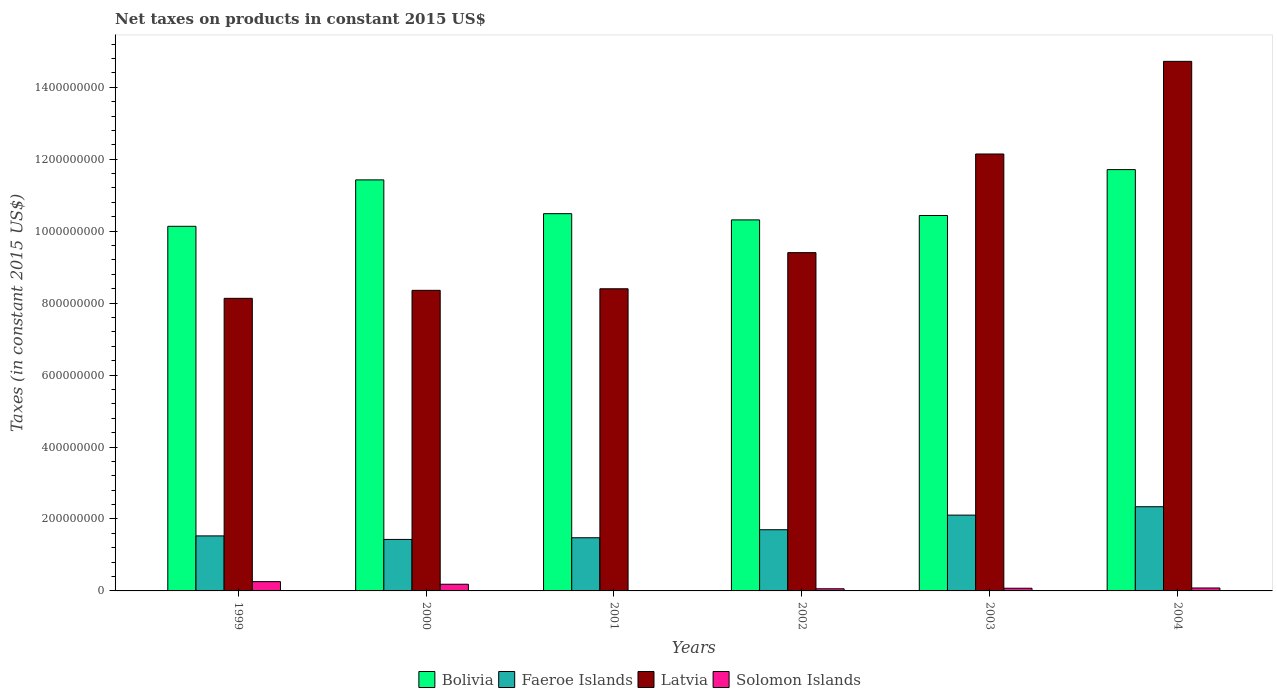How many groups of bars are there?
Give a very brief answer. 6. How many bars are there on the 6th tick from the right?
Give a very brief answer. 4. What is the net taxes on products in Faeroe Islands in 2002?
Offer a very short reply. 1.70e+08. Across all years, what is the maximum net taxes on products in Bolivia?
Provide a short and direct response. 1.17e+09. Across all years, what is the minimum net taxes on products in Latvia?
Give a very brief answer. 8.13e+08. In which year was the net taxes on products in Latvia maximum?
Keep it short and to the point. 2004. What is the total net taxes on products in Latvia in the graph?
Offer a very short reply. 6.12e+09. What is the difference between the net taxes on products in Faeroe Islands in 1999 and that in 2002?
Make the answer very short. -1.72e+07. What is the difference between the net taxes on products in Bolivia in 2003 and the net taxes on products in Latvia in 2004?
Your answer should be compact. -4.28e+08. What is the average net taxes on products in Solomon Islands per year?
Offer a very short reply. 1.10e+07. In the year 2003, what is the difference between the net taxes on products in Latvia and net taxes on products in Faeroe Islands?
Provide a succinct answer. 1.00e+09. In how many years, is the net taxes on products in Solomon Islands greater than 280000000 US$?
Keep it short and to the point. 0. What is the ratio of the net taxes on products in Solomon Islands in 2000 to that in 2002?
Your answer should be compact. 3.1. What is the difference between the highest and the second highest net taxes on products in Solomon Islands?
Make the answer very short. 7.27e+06. What is the difference between the highest and the lowest net taxes on products in Bolivia?
Offer a terse response. 1.58e+08. Is the sum of the net taxes on products in Latvia in 2000 and 2002 greater than the maximum net taxes on products in Solomon Islands across all years?
Provide a short and direct response. Yes. Is it the case that in every year, the sum of the net taxes on products in Latvia and net taxes on products in Bolivia is greater than the net taxes on products in Solomon Islands?
Provide a short and direct response. Yes. How many bars are there?
Offer a very short reply. 23. What is the difference between two consecutive major ticks on the Y-axis?
Your answer should be compact. 2.00e+08. Are the values on the major ticks of Y-axis written in scientific E-notation?
Keep it short and to the point. No. Does the graph contain grids?
Your response must be concise. No. Where does the legend appear in the graph?
Your response must be concise. Bottom center. How are the legend labels stacked?
Provide a short and direct response. Horizontal. What is the title of the graph?
Your answer should be compact. Net taxes on products in constant 2015 US$. What is the label or title of the Y-axis?
Provide a short and direct response. Taxes (in constant 2015 US$). What is the Taxes (in constant 2015 US$) in Bolivia in 1999?
Your answer should be compact. 1.01e+09. What is the Taxes (in constant 2015 US$) of Faeroe Islands in 1999?
Your answer should be compact. 1.53e+08. What is the Taxes (in constant 2015 US$) of Latvia in 1999?
Make the answer very short. 8.13e+08. What is the Taxes (in constant 2015 US$) in Solomon Islands in 1999?
Offer a terse response. 2.58e+07. What is the Taxes (in constant 2015 US$) in Bolivia in 2000?
Keep it short and to the point. 1.14e+09. What is the Taxes (in constant 2015 US$) of Faeroe Islands in 2000?
Your response must be concise. 1.43e+08. What is the Taxes (in constant 2015 US$) of Latvia in 2000?
Your answer should be compact. 8.36e+08. What is the Taxes (in constant 2015 US$) in Solomon Islands in 2000?
Offer a very short reply. 1.86e+07. What is the Taxes (in constant 2015 US$) of Bolivia in 2001?
Make the answer very short. 1.05e+09. What is the Taxes (in constant 2015 US$) of Faeroe Islands in 2001?
Offer a terse response. 1.48e+08. What is the Taxes (in constant 2015 US$) in Latvia in 2001?
Make the answer very short. 8.40e+08. What is the Taxes (in constant 2015 US$) in Bolivia in 2002?
Your answer should be compact. 1.03e+09. What is the Taxes (in constant 2015 US$) in Faeroe Islands in 2002?
Make the answer very short. 1.70e+08. What is the Taxes (in constant 2015 US$) in Latvia in 2002?
Your response must be concise. 9.40e+08. What is the Taxes (in constant 2015 US$) of Solomon Islands in 2002?
Your answer should be compact. 5.98e+06. What is the Taxes (in constant 2015 US$) in Bolivia in 2003?
Your answer should be very brief. 1.04e+09. What is the Taxes (in constant 2015 US$) of Faeroe Islands in 2003?
Your response must be concise. 2.11e+08. What is the Taxes (in constant 2015 US$) in Latvia in 2003?
Offer a terse response. 1.21e+09. What is the Taxes (in constant 2015 US$) of Solomon Islands in 2003?
Your response must be concise. 7.43e+06. What is the Taxes (in constant 2015 US$) of Bolivia in 2004?
Your response must be concise. 1.17e+09. What is the Taxes (in constant 2015 US$) of Faeroe Islands in 2004?
Offer a terse response. 2.34e+08. What is the Taxes (in constant 2015 US$) in Latvia in 2004?
Offer a terse response. 1.47e+09. What is the Taxes (in constant 2015 US$) of Solomon Islands in 2004?
Make the answer very short. 8.16e+06. Across all years, what is the maximum Taxes (in constant 2015 US$) in Bolivia?
Your answer should be compact. 1.17e+09. Across all years, what is the maximum Taxes (in constant 2015 US$) in Faeroe Islands?
Make the answer very short. 2.34e+08. Across all years, what is the maximum Taxes (in constant 2015 US$) in Latvia?
Keep it short and to the point. 1.47e+09. Across all years, what is the maximum Taxes (in constant 2015 US$) in Solomon Islands?
Your answer should be very brief. 2.58e+07. Across all years, what is the minimum Taxes (in constant 2015 US$) of Bolivia?
Provide a short and direct response. 1.01e+09. Across all years, what is the minimum Taxes (in constant 2015 US$) of Faeroe Islands?
Your answer should be very brief. 1.43e+08. Across all years, what is the minimum Taxes (in constant 2015 US$) of Latvia?
Your answer should be very brief. 8.13e+08. What is the total Taxes (in constant 2015 US$) in Bolivia in the graph?
Ensure brevity in your answer.  6.45e+09. What is the total Taxes (in constant 2015 US$) in Faeroe Islands in the graph?
Your response must be concise. 1.06e+09. What is the total Taxes (in constant 2015 US$) in Latvia in the graph?
Offer a terse response. 6.12e+09. What is the total Taxes (in constant 2015 US$) in Solomon Islands in the graph?
Offer a terse response. 6.59e+07. What is the difference between the Taxes (in constant 2015 US$) in Bolivia in 1999 and that in 2000?
Provide a succinct answer. -1.29e+08. What is the difference between the Taxes (in constant 2015 US$) of Faeroe Islands in 1999 and that in 2000?
Make the answer very short. 9.81e+06. What is the difference between the Taxes (in constant 2015 US$) of Latvia in 1999 and that in 2000?
Your response must be concise. -2.22e+07. What is the difference between the Taxes (in constant 2015 US$) in Solomon Islands in 1999 and that in 2000?
Your response must be concise. 7.27e+06. What is the difference between the Taxes (in constant 2015 US$) of Bolivia in 1999 and that in 2001?
Provide a short and direct response. -3.51e+07. What is the difference between the Taxes (in constant 2015 US$) of Faeroe Islands in 1999 and that in 2001?
Keep it short and to the point. 5.16e+06. What is the difference between the Taxes (in constant 2015 US$) of Latvia in 1999 and that in 2001?
Keep it short and to the point. -2.66e+07. What is the difference between the Taxes (in constant 2015 US$) of Bolivia in 1999 and that in 2002?
Keep it short and to the point. -1.78e+07. What is the difference between the Taxes (in constant 2015 US$) of Faeroe Islands in 1999 and that in 2002?
Your answer should be compact. -1.72e+07. What is the difference between the Taxes (in constant 2015 US$) of Latvia in 1999 and that in 2002?
Ensure brevity in your answer.  -1.27e+08. What is the difference between the Taxes (in constant 2015 US$) in Solomon Islands in 1999 and that in 2002?
Provide a succinct answer. 1.98e+07. What is the difference between the Taxes (in constant 2015 US$) in Bolivia in 1999 and that in 2003?
Offer a terse response. -3.01e+07. What is the difference between the Taxes (in constant 2015 US$) in Faeroe Islands in 1999 and that in 2003?
Offer a terse response. -5.77e+07. What is the difference between the Taxes (in constant 2015 US$) in Latvia in 1999 and that in 2003?
Keep it short and to the point. -4.01e+08. What is the difference between the Taxes (in constant 2015 US$) of Solomon Islands in 1999 and that in 2003?
Your answer should be very brief. 1.84e+07. What is the difference between the Taxes (in constant 2015 US$) in Bolivia in 1999 and that in 2004?
Make the answer very short. -1.58e+08. What is the difference between the Taxes (in constant 2015 US$) in Faeroe Islands in 1999 and that in 2004?
Provide a short and direct response. -8.11e+07. What is the difference between the Taxes (in constant 2015 US$) in Latvia in 1999 and that in 2004?
Give a very brief answer. -6.59e+08. What is the difference between the Taxes (in constant 2015 US$) in Solomon Islands in 1999 and that in 2004?
Your answer should be very brief. 1.77e+07. What is the difference between the Taxes (in constant 2015 US$) in Bolivia in 2000 and that in 2001?
Provide a short and direct response. 9.39e+07. What is the difference between the Taxes (in constant 2015 US$) of Faeroe Islands in 2000 and that in 2001?
Provide a succinct answer. -4.65e+06. What is the difference between the Taxes (in constant 2015 US$) of Latvia in 2000 and that in 2001?
Make the answer very short. -4.34e+06. What is the difference between the Taxes (in constant 2015 US$) of Bolivia in 2000 and that in 2002?
Your response must be concise. 1.11e+08. What is the difference between the Taxes (in constant 2015 US$) of Faeroe Islands in 2000 and that in 2002?
Offer a terse response. -2.70e+07. What is the difference between the Taxes (in constant 2015 US$) of Latvia in 2000 and that in 2002?
Keep it short and to the point. -1.05e+08. What is the difference between the Taxes (in constant 2015 US$) in Solomon Islands in 2000 and that in 2002?
Your answer should be compact. 1.26e+07. What is the difference between the Taxes (in constant 2015 US$) of Bolivia in 2000 and that in 2003?
Keep it short and to the point. 9.90e+07. What is the difference between the Taxes (in constant 2015 US$) of Faeroe Islands in 2000 and that in 2003?
Offer a terse response. -6.76e+07. What is the difference between the Taxes (in constant 2015 US$) in Latvia in 2000 and that in 2003?
Your response must be concise. -3.79e+08. What is the difference between the Taxes (in constant 2015 US$) of Solomon Islands in 2000 and that in 2003?
Provide a succinct answer. 1.11e+07. What is the difference between the Taxes (in constant 2015 US$) of Bolivia in 2000 and that in 2004?
Provide a short and direct response. -2.86e+07. What is the difference between the Taxes (in constant 2015 US$) in Faeroe Islands in 2000 and that in 2004?
Offer a very short reply. -9.09e+07. What is the difference between the Taxes (in constant 2015 US$) in Latvia in 2000 and that in 2004?
Your answer should be very brief. -6.36e+08. What is the difference between the Taxes (in constant 2015 US$) of Solomon Islands in 2000 and that in 2004?
Keep it short and to the point. 1.04e+07. What is the difference between the Taxes (in constant 2015 US$) of Bolivia in 2001 and that in 2002?
Your answer should be very brief. 1.73e+07. What is the difference between the Taxes (in constant 2015 US$) in Faeroe Islands in 2001 and that in 2002?
Offer a very short reply. -2.23e+07. What is the difference between the Taxes (in constant 2015 US$) in Latvia in 2001 and that in 2002?
Ensure brevity in your answer.  -1.00e+08. What is the difference between the Taxes (in constant 2015 US$) of Bolivia in 2001 and that in 2003?
Ensure brevity in your answer.  5.02e+06. What is the difference between the Taxes (in constant 2015 US$) of Faeroe Islands in 2001 and that in 2003?
Your answer should be very brief. -6.29e+07. What is the difference between the Taxes (in constant 2015 US$) in Latvia in 2001 and that in 2003?
Offer a very short reply. -3.75e+08. What is the difference between the Taxes (in constant 2015 US$) in Bolivia in 2001 and that in 2004?
Your answer should be very brief. -1.23e+08. What is the difference between the Taxes (in constant 2015 US$) in Faeroe Islands in 2001 and that in 2004?
Make the answer very short. -8.62e+07. What is the difference between the Taxes (in constant 2015 US$) in Latvia in 2001 and that in 2004?
Make the answer very short. -6.32e+08. What is the difference between the Taxes (in constant 2015 US$) in Bolivia in 2002 and that in 2003?
Offer a very short reply. -1.23e+07. What is the difference between the Taxes (in constant 2015 US$) of Faeroe Islands in 2002 and that in 2003?
Make the answer very short. -4.06e+07. What is the difference between the Taxes (in constant 2015 US$) of Latvia in 2002 and that in 2003?
Provide a short and direct response. -2.74e+08. What is the difference between the Taxes (in constant 2015 US$) in Solomon Islands in 2002 and that in 2003?
Make the answer very short. -1.46e+06. What is the difference between the Taxes (in constant 2015 US$) of Bolivia in 2002 and that in 2004?
Ensure brevity in your answer.  -1.40e+08. What is the difference between the Taxes (in constant 2015 US$) in Faeroe Islands in 2002 and that in 2004?
Your answer should be compact. -6.39e+07. What is the difference between the Taxes (in constant 2015 US$) of Latvia in 2002 and that in 2004?
Provide a succinct answer. -5.32e+08. What is the difference between the Taxes (in constant 2015 US$) in Solomon Islands in 2002 and that in 2004?
Keep it short and to the point. -2.18e+06. What is the difference between the Taxes (in constant 2015 US$) in Bolivia in 2003 and that in 2004?
Make the answer very short. -1.28e+08. What is the difference between the Taxes (in constant 2015 US$) in Faeroe Islands in 2003 and that in 2004?
Offer a terse response. -2.33e+07. What is the difference between the Taxes (in constant 2015 US$) of Latvia in 2003 and that in 2004?
Offer a terse response. -2.58e+08. What is the difference between the Taxes (in constant 2015 US$) of Solomon Islands in 2003 and that in 2004?
Keep it short and to the point. -7.29e+05. What is the difference between the Taxes (in constant 2015 US$) of Bolivia in 1999 and the Taxes (in constant 2015 US$) of Faeroe Islands in 2000?
Give a very brief answer. 8.70e+08. What is the difference between the Taxes (in constant 2015 US$) in Bolivia in 1999 and the Taxes (in constant 2015 US$) in Latvia in 2000?
Provide a succinct answer. 1.78e+08. What is the difference between the Taxes (in constant 2015 US$) in Bolivia in 1999 and the Taxes (in constant 2015 US$) in Solomon Islands in 2000?
Provide a short and direct response. 9.95e+08. What is the difference between the Taxes (in constant 2015 US$) of Faeroe Islands in 1999 and the Taxes (in constant 2015 US$) of Latvia in 2000?
Your response must be concise. -6.83e+08. What is the difference between the Taxes (in constant 2015 US$) of Faeroe Islands in 1999 and the Taxes (in constant 2015 US$) of Solomon Islands in 2000?
Keep it short and to the point. 1.34e+08. What is the difference between the Taxes (in constant 2015 US$) in Latvia in 1999 and the Taxes (in constant 2015 US$) in Solomon Islands in 2000?
Your response must be concise. 7.95e+08. What is the difference between the Taxes (in constant 2015 US$) of Bolivia in 1999 and the Taxes (in constant 2015 US$) of Faeroe Islands in 2001?
Provide a short and direct response. 8.66e+08. What is the difference between the Taxes (in constant 2015 US$) of Bolivia in 1999 and the Taxes (in constant 2015 US$) of Latvia in 2001?
Offer a terse response. 1.74e+08. What is the difference between the Taxes (in constant 2015 US$) of Faeroe Islands in 1999 and the Taxes (in constant 2015 US$) of Latvia in 2001?
Provide a succinct answer. -6.87e+08. What is the difference between the Taxes (in constant 2015 US$) in Bolivia in 1999 and the Taxes (in constant 2015 US$) in Faeroe Islands in 2002?
Your answer should be very brief. 8.43e+08. What is the difference between the Taxes (in constant 2015 US$) in Bolivia in 1999 and the Taxes (in constant 2015 US$) in Latvia in 2002?
Your response must be concise. 7.32e+07. What is the difference between the Taxes (in constant 2015 US$) of Bolivia in 1999 and the Taxes (in constant 2015 US$) of Solomon Islands in 2002?
Offer a very short reply. 1.01e+09. What is the difference between the Taxes (in constant 2015 US$) of Faeroe Islands in 1999 and the Taxes (in constant 2015 US$) of Latvia in 2002?
Make the answer very short. -7.87e+08. What is the difference between the Taxes (in constant 2015 US$) in Faeroe Islands in 1999 and the Taxes (in constant 2015 US$) in Solomon Islands in 2002?
Keep it short and to the point. 1.47e+08. What is the difference between the Taxes (in constant 2015 US$) in Latvia in 1999 and the Taxes (in constant 2015 US$) in Solomon Islands in 2002?
Make the answer very short. 8.07e+08. What is the difference between the Taxes (in constant 2015 US$) in Bolivia in 1999 and the Taxes (in constant 2015 US$) in Faeroe Islands in 2003?
Keep it short and to the point. 8.03e+08. What is the difference between the Taxes (in constant 2015 US$) in Bolivia in 1999 and the Taxes (in constant 2015 US$) in Latvia in 2003?
Your answer should be very brief. -2.01e+08. What is the difference between the Taxes (in constant 2015 US$) of Bolivia in 1999 and the Taxes (in constant 2015 US$) of Solomon Islands in 2003?
Your response must be concise. 1.01e+09. What is the difference between the Taxes (in constant 2015 US$) of Faeroe Islands in 1999 and the Taxes (in constant 2015 US$) of Latvia in 2003?
Your answer should be very brief. -1.06e+09. What is the difference between the Taxes (in constant 2015 US$) of Faeroe Islands in 1999 and the Taxes (in constant 2015 US$) of Solomon Islands in 2003?
Make the answer very short. 1.46e+08. What is the difference between the Taxes (in constant 2015 US$) of Latvia in 1999 and the Taxes (in constant 2015 US$) of Solomon Islands in 2003?
Offer a very short reply. 8.06e+08. What is the difference between the Taxes (in constant 2015 US$) in Bolivia in 1999 and the Taxes (in constant 2015 US$) in Faeroe Islands in 2004?
Give a very brief answer. 7.80e+08. What is the difference between the Taxes (in constant 2015 US$) in Bolivia in 1999 and the Taxes (in constant 2015 US$) in Latvia in 2004?
Your response must be concise. -4.59e+08. What is the difference between the Taxes (in constant 2015 US$) of Bolivia in 1999 and the Taxes (in constant 2015 US$) of Solomon Islands in 2004?
Provide a succinct answer. 1.01e+09. What is the difference between the Taxes (in constant 2015 US$) in Faeroe Islands in 1999 and the Taxes (in constant 2015 US$) in Latvia in 2004?
Give a very brief answer. -1.32e+09. What is the difference between the Taxes (in constant 2015 US$) in Faeroe Islands in 1999 and the Taxes (in constant 2015 US$) in Solomon Islands in 2004?
Keep it short and to the point. 1.45e+08. What is the difference between the Taxes (in constant 2015 US$) in Latvia in 1999 and the Taxes (in constant 2015 US$) in Solomon Islands in 2004?
Provide a succinct answer. 8.05e+08. What is the difference between the Taxes (in constant 2015 US$) of Bolivia in 2000 and the Taxes (in constant 2015 US$) of Faeroe Islands in 2001?
Give a very brief answer. 9.95e+08. What is the difference between the Taxes (in constant 2015 US$) of Bolivia in 2000 and the Taxes (in constant 2015 US$) of Latvia in 2001?
Provide a short and direct response. 3.03e+08. What is the difference between the Taxes (in constant 2015 US$) in Faeroe Islands in 2000 and the Taxes (in constant 2015 US$) in Latvia in 2001?
Give a very brief answer. -6.97e+08. What is the difference between the Taxes (in constant 2015 US$) in Bolivia in 2000 and the Taxes (in constant 2015 US$) in Faeroe Islands in 2002?
Your answer should be compact. 9.72e+08. What is the difference between the Taxes (in constant 2015 US$) in Bolivia in 2000 and the Taxes (in constant 2015 US$) in Latvia in 2002?
Give a very brief answer. 2.02e+08. What is the difference between the Taxes (in constant 2015 US$) in Bolivia in 2000 and the Taxes (in constant 2015 US$) in Solomon Islands in 2002?
Give a very brief answer. 1.14e+09. What is the difference between the Taxes (in constant 2015 US$) of Faeroe Islands in 2000 and the Taxes (in constant 2015 US$) of Latvia in 2002?
Your answer should be very brief. -7.97e+08. What is the difference between the Taxes (in constant 2015 US$) of Faeroe Islands in 2000 and the Taxes (in constant 2015 US$) of Solomon Islands in 2002?
Offer a terse response. 1.37e+08. What is the difference between the Taxes (in constant 2015 US$) of Latvia in 2000 and the Taxes (in constant 2015 US$) of Solomon Islands in 2002?
Your response must be concise. 8.30e+08. What is the difference between the Taxes (in constant 2015 US$) of Bolivia in 2000 and the Taxes (in constant 2015 US$) of Faeroe Islands in 2003?
Offer a terse response. 9.32e+08. What is the difference between the Taxes (in constant 2015 US$) in Bolivia in 2000 and the Taxes (in constant 2015 US$) in Latvia in 2003?
Give a very brief answer. -7.20e+07. What is the difference between the Taxes (in constant 2015 US$) of Bolivia in 2000 and the Taxes (in constant 2015 US$) of Solomon Islands in 2003?
Give a very brief answer. 1.14e+09. What is the difference between the Taxes (in constant 2015 US$) of Faeroe Islands in 2000 and the Taxes (in constant 2015 US$) of Latvia in 2003?
Keep it short and to the point. -1.07e+09. What is the difference between the Taxes (in constant 2015 US$) in Faeroe Islands in 2000 and the Taxes (in constant 2015 US$) in Solomon Islands in 2003?
Keep it short and to the point. 1.36e+08. What is the difference between the Taxes (in constant 2015 US$) of Latvia in 2000 and the Taxes (in constant 2015 US$) of Solomon Islands in 2003?
Keep it short and to the point. 8.28e+08. What is the difference between the Taxes (in constant 2015 US$) in Bolivia in 2000 and the Taxes (in constant 2015 US$) in Faeroe Islands in 2004?
Your answer should be compact. 9.09e+08. What is the difference between the Taxes (in constant 2015 US$) in Bolivia in 2000 and the Taxes (in constant 2015 US$) in Latvia in 2004?
Give a very brief answer. -3.29e+08. What is the difference between the Taxes (in constant 2015 US$) of Bolivia in 2000 and the Taxes (in constant 2015 US$) of Solomon Islands in 2004?
Offer a terse response. 1.13e+09. What is the difference between the Taxes (in constant 2015 US$) in Faeroe Islands in 2000 and the Taxes (in constant 2015 US$) in Latvia in 2004?
Provide a succinct answer. -1.33e+09. What is the difference between the Taxes (in constant 2015 US$) in Faeroe Islands in 2000 and the Taxes (in constant 2015 US$) in Solomon Islands in 2004?
Your answer should be very brief. 1.35e+08. What is the difference between the Taxes (in constant 2015 US$) in Latvia in 2000 and the Taxes (in constant 2015 US$) in Solomon Islands in 2004?
Ensure brevity in your answer.  8.27e+08. What is the difference between the Taxes (in constant 2015 US$) in Bolivia in 2001 and the Taxes (in constant 2015 US$) in Faeroe Islands in 2002?
Give a very brief answer. 8.79e+08. What is the difference between the Taxes (in constant 2015 US$) of Bolivia in 2001 and the Taxes (in constant 2015 US$) of Latvia in 2002?
Provide a short and direct response. 1.08e+08. What is the difference between the Taxes (in constant 2015 US$) in Bolivia in 2001 and the Taxes (in constant 2015 US$) in Solomon Islands in 2002?
Offer a terse response. 1.04e+09. What is the difference between the Taxes (in constant 2015 US$) of Faeroe Islands in 2001 and the Taxes (in constant 2015 US$) of Latvia in 2002?
Provide a succinct answer. -7.93e+08. What is the difference between the Taxes (in constant 2015 US$) of Faeroe Islands in 2001 and the Taxes (in constant 2015 US$) of Solomon Islands in 2002?
Offer a terse response. 1.42e+08. What is the difference between the Taxes (in constant 2015 US$) in Latvia in 2001 and the Taxes (in constant 2015 US$) in Solomon Islands in 2002?
Offer a very short reply. 8.34e+08. What is the difference between the Taxes (in constant 2015 US$) of Bolivia in 2001 and the Taxes (in constant 2015 US$) of Faeroe Islands in 2003?
Your response must be concise. 8.38e+08. What is the difference between the Taxes (in constant 2015 US$) in Bolivia in 2001 and the Taxes (in constant 2015 US$) in Latvia in 2003?
Your answer should be compact. -1.66e+08. What is the difference between the Taxes (in constant 2015 US$) in Bolivia in 2001 and the Taxes (in constant 2015 US$) in Solomon Islands in 2003?
Offer a very short reply. 1.04e+09. What is the difference between the Taxes (in constant 2015 US$) in Faeroe Islands in 2001 and the Taxes (in constant 2015 US$) in Latvia in 2003?
Your answer should be very brief. -1.07e+09. What is the difference between the Taxes (in constant 2015 US$) of Faeroe Islands in 2001 and the Taxes (in constant 2015 US$) of Solomon Islands in 2003?
Offer a terse response. 1.40e+08. What is the difference between the Taxes (in constant 2015 US$) of Latvia in 2001 and the Taxes (in constant 2015 US$) of Solomon Islands in 2003?
Make the answer very short. 8.32e+08. What is the difference between the Taxes (in constant 2015 US$) in Bolivia in 2001 and the Taxes (in constant 2015 US$) in Faeroe Islands in 2004?
Your answer should be compact. 8.15e+08. What is the difference between the Taxes (in constant 2015 US$) in Bolivia in 2001 and the Taxes (in constant 2015 US$) in Latvia in 2004?
Ensure brevity in your answer.  -4.23e+08. What is the difference between the Taxes (in constant 2015 US$) in Bolivia in 2001 and the Taxes (in constant 2015 US$) in Solomon Islands in 2004?
Your answer should be compact. 1.04e+09. What is the difference between the Taxes (in constant 2015 US$) of Faeroe Islands in 2001 and the Taxes (in constant 2015 US$) of Latvia in 2004?
Give a very brief answer. -1.32e+09. What is the difference between the Taxes (in constant 2015 US$) in Faeroe Islands in 2001 and the Taxes (in constant 2015 US$) in Solomon Islands in 2004?
Your answer should be very brief. 1.40e+08. What is the difference between the Taxes (in constant 2015 US$) in Latvia in 2001 and the Taxes (in constant 2015 US$) in Solomon Islands in 2004?
Your answer should be compact. 8.32e+08. What is the difference between the Taxes (in constant 2015 US$) in Bolivia in 2002 and the Taxes (in constant 2015 US$) in Faeroe Islands in 2003?
Your response must be concise. 8.21e+08. What is the difference between the Taxes (in constant 2015 US$) in Bolivia in 2002 and the Taxes (in constant 2015 US$) in Latvia in 2003?
Your answer should be compact. -1.83e+08. What is the difference between the Taxes (in constant 2015 US$) of Bolivia in 2002 and the Taxes (in constant 2015 US$) of Solomon Islands in 2003?
Offer a very short reply. 1.02e+09. What is the difference between the Taxes (in constant 2015 US$) in Faeroe Islands in 2002 and the Taxes (in constant 2015 US$) in Latvia in 2003?
Keep it short and to the point. -1.04e+09. What is the difference between the Taxes (in constant 2015 US$) of Faeroe Islands in 2002 and the Taxes (in constant 2015 US$) of Solomon Islands in 2003?
Your response must be concise. 1.63e+08. What is the difference between the Taxes (in constant 2015 US$) in Latvia in 2002 and the Taxes (in constant 2015 US$) in Solomon Islands in 2003?
Your answer should be very brief. 9.33e+08. What is the difference between the Taxes (in constant 2015 US$) of Bolivia in 2002 and the Taxes (in constant 2015 US$) of Faeroe Islands in 2004?
Your answer should be compact. 7.97e+08. What is the difference between the Taxes (in constant 2015 US$) in Bolivia in 2002 and the Taxes (in constant 2015 US$) in Latvia in 2004?
Provide a short and direct response. -4.41e+08. What is the difference between the Taxes (in constant 2015 US$) of Bolivia in 2002 and the Taxes (in constant 2015 US$) of Solomon Islands in 2004?
Keep it short and to the point. 1.02e+09. What is the difference between the Taxes (in constant 2015 US$) of Faeroe Islands in 2002 and the Taxes (in constant 2015 US$) of Latvia in 2004?
Ensure brevity in your answer.  -1.30e+09. What is the difference between the Taxes (in constant 2015 US$) in Faeroe Islands in 2002 and the Taxes (in constant 2015 US$) in Solomon Islands in 2004?
Give a very brief answer. 1.62e+08. What is the difference between the Taxes (in constant 2015 US$) of Latvia in 2002 and the Taxes (in constant 2015 US$) of Solomon Islands in 2004?
Provide a succinct answer. 9.32e+08. What is the difference between the Taxes (in constant 2015 US$) of Bolivia in 2003 and the Taxes (in constant 2015 US$) of Faeroe Islands in 2004?
Make the answer very short. 8.10e+08. What is the difference between the Taxes (in constant 2015 US$) of Bolivia in 2003 and the Taxes (in constant 2015 US$) of Latvia in 2004?
Offer a terse response. -4.28e+08. What is the difference between the Taxes (in constant 2015 US$) in Bolivia in 2003 and the Taxes (in constant 2015 US$) in Solomon Islands in 2004?
Your answer should be very brief. 1.04e+09. What is the difference between the Taxes (in constant 2015 US$) in Faeroe Islands in 2003 and the Taxes (in constant 2015 US$) in Latvia in 2004?
Provide a succinct answer. -1.26e+09. What is the difference between the Taxes (in constant 2015 US$) of Faeroe Islands in 2003 and the Taxes (in constant 2015 US$) of Solomon Islands in 2004?
Keep it short and to the point. 2.03e+08. What is the difference between the Taxes (in constant 2015 US$) in Latvia in 2003 and the Taxes (in constant 2015 US$) in Solomon Islands in 2004?
Make the answer very short. 1.21e+09. What is the average Taxes (in constant 2015 US$) of Bolivia per year?
Ensure brevity in your answer.  1.08e+09. What is the average Taxes (in constant 2015 US$) of Faeroe Islands per year?
Ensure brevity in your answer.  1.76e+08. What is the average Taxes (in constant 2015 US$) in Latvia per year?
Provide a succinct answer. 1.02e+09. What is the average Taxes (in constant 2015 US$) in Solomon Islands per year?
Your response must be concise. 1.10e+07. In the year 1999, what is the difference between the Taxes (in constant 2015 US$) of Bolivia and Taxes (in constant 2015 US$) of Faeroe Islands?
Keep it short and to the point. 8.61e+08. In the year 1999, what is the difference between the Taxes (in constant 2015 US$) of Bolivia and Taxes (in constant 2015 US$) of Latvia?
Give a very brief answer. 2.00e+08. In the year 1999, what is the difference between the Taxes (in constant 2015 US$) in Bolivia and Taxes (in constant 2015 US$) in Solomon Islands?
Make the answer very short. 9.88e+08. In the year 1999, what is the difference between the Taxes (in constant 2015 US$) in Faeroe Islands and Taxes (in constant 2015 US$) in Latvia?
Your answer should be compact. -6.60e+08. In the year 1999, what is the difference between the Taxes (in constant 2015 US$) of Faeroe Islands and Taxes (in constant 2015 US$) of Solomon Islands?
Provide a succinct answer. 1.27e+08. In the year 1999, what is the difference between the Taxes (in constant 2015 US$) of Latvia and Taxes (in constant 2015 US$) of Solomon Islands?
Offer a very short reply. 7.87e+08. In the year 2000, what is the difference between the Taxes (in constant 2015 US$) of Bolivia and Taxes (in constant 2015 US$) of Faeroe Islands?
Ensure brevity in your answer.  9.99e+08. In the year 2000, what is the difference between the Taxes (in constant 2015 US$) in Bolivia and Taxes (in constant 2015 US$) in Latvia?
Offer a very short reply. 3.07e+08. In the year 2000, what is the difference between the Taxes (in constant 2015 US$) of Bolivia and Taxes (in constant 2015 US$) of Solomon Islands?
Give a very brief answer. 1.12e+09. In the year 2000, what is the difference between the Taxes (in constant 2015 US$) in Faeroe Islands and Taxes (in constant 2015 US$) in Latvia?
Ensure brevity in your answer.  -6.92e+08. In the year 2000, what is the difference between the Taxes (in constant 2015 US$) in Faeroe Islands and Taxes (in constant 2015 US$) in Solomon Islands?
Offer a terse response. 1.25e+08. In the year 2000, what is the difference between the Taxes (in constant 2015 US$) of Latvia and Taxes (in constant 2015 US$) of Solomon Islands?
Keep it short and to the point. 8.17e+08. In the year 2001, what is the difference between the Taxes (in constant 2015 US$) of Bolivia and Taxes (in constant 2015 US$) of Faeroe Islands?
Ensure brevity in your answer.  9.01e+08. In the year 2001, what is the difference between the Taxes (in constant 2015 US$) of Bolivia and Taxes (in constant 2015 US$) of Latvia?
Provide a succinct answer. 2.09e+08. In the year 2001, what is the difference between the Taxes (in constant 2015 US$) of Faeroe Islands and Taxes (in constant 2015 US$) of Latvia?
Provide a succinct answer. -6.92e+08. In the year 2002, what is the difference between the Taxes (in constant 2015 US$) in Bolivia and Taxes (in constant 2015 US$) in Faeroe Islands?
Provide a short and direct response. 8.61e+08. In the year 2002, what is the difference between the Taxes (in constant 2015 US$) in Bolivia and Taxes (in constant 2015 US$) in Latvia?
Provide a succinct answer. 9.10e+07. In the year 2002, what is the difference between the Taxes (in constant 2015 US$) in Bolivia and Taxes (in constant 2015 US$) in Solomon Islands?
Keep it short and to the point. 1.03e+09. In the year 2002, what is the difference between the Taxes (in constant 2015 US$) in Faeroe Islands and Taxes (in constant 2015 US$) in Latvia?
Give a very brief answer. -7.70e+08. In the year 2002, what is the difference between the Taxes (in constant 2015 US$) in Faeroe Islands and Taxes (in constant 2015 US$) in Solomon Islands?
Ensure brevity in your answer.  1.64e+08. In the year 2002, what is the difference between the Taxes (in constant 2015 US$) in Latvia and Taxes (in constant 2015 US$) in Solomon Islands?
Provide a succinct answer. 9.34e+08. In the year 2003, what is the difference between the Taxes (in constant 2015 US$) of Bolivia and Taxes (in constant 2015 US$) of Faeroe Islands?
Give a very brief answer. 8.33e+08. In the year 2003, what is the difference between the Taxes (in constant 2015 US$) of Bolivia and Taxes (in constant 2015 US$) of Latvia?
Give a very brief answer. -1.71e+08. In the year 2003, what is the difference between the Taxes (in constant 2015 US$) in Bolivia and Taxes (in constant 2015 US$) in Solomon Islands?
Provide a short and direct response. 1.04e+09. In the year 2003, what is the difference between the Taxes (in constant 2015 US$) of Faeroe Islands and Taxes (in constant 2015 US$) of Latvia?
Provide a succinct answer. -1.00e+09. In the year 2003, what is the difference between the Taxes (in constant 2015 US$) of Faeroe Islands and Taxes (in constant 2015 US$) of Solomon Islands?
Give a very brief answer. 2.03e+08. In the year 2003, what is the difference between the Taxes (in constant 2015 US$) in Latvia and Taxes (in constant 2015 US$) in Solomon Islands?
Offer a terse response. 1.21e+09. In the year 2004, what is the difference between the Taxes (in constant 2015 US$) in Bolivia and Taxes (in constant 2015 US$) in Faeroe Islands?
Provide a succinct answer. 9.37e+08. In the year 2004, what is the difference between the Taxes (in constant 2015 US$) of Bolivia and Taxes (in constant 2015 US$) of Latvia?
Your response must be concise. -3.01e+08. In the year 2004, what is the difference between the Taxes (in constant 2015 US$) of Bolivia and Taxes (in constant 2015 US$) of Solomon Islands?
Your answer should be very brief. 1.16e+09. In the year 2004, what is the difference between the Taxes (in constant 2015 US$) in Faeroe Islands and Taxes (in constant 2015 US$) in Latvia?
Your answer should be very brief. -1.24e+09. In the year 2004, what is the difference between the Taxes (in constant 2015 US$) of Faeroe Islands and Taxes (in constant 2015 US$) of Solomon Islands?
Your answer should be very brief. 2.26e+08. In the year 2004, what is the difference between the Taxes (in constant 2015 US$) in Latvia and Taxes (in constant 2015 US$) in Solomon Islands?
Keep it short and to the point. 1.46e+09. What is the ratio of the Taxes (in constant 2015 US$) in Bolivia in 1999 to that in 2000?
Offer a very short reply. 0.89. What is the ratio of the Taxes (in constant 2015 US$) of Faeroe Islands in 1999 to that in 2000?
Offer a terse response. 1.07. What is the ratio of the Taxes (in constant 2015 US$) in Latvia in 1999 to that in 2000?
Provide a short and direct response. 0.97. What is the ratio of the Taxes (in constant 2015 US$) in Solomon Islands in 1999 to that in 2000?
Offer a very short reply. 1.39. What is the ratio of the Taxes (in constant 2015 US$) of Bolivia in 1999 to that in 2001?
Keep it short and to the point. 0.97. What is the ratio of the Taxes (in constant 2015 US$) in Faeroe Islands in 1999 to that in 2001?
Provide a short and direct response. 1.03. What is the ratio of the Taxes (in constant 2015 US$) of Latvia in 1999 to that in 2001?
Make the answer very short. 0.97. What is the ratio of the Taxes (in constant 2015 US$) of Bolivia in 1999 to that in 2002?
Keep it short and to the point. 0.98. What is the ratio of the Taxes (in constant 2015 US$) in Faeroe Islands in 1999 to that in 2002?
Offer a terse response. 0.9. What is the ratio of the Taxes (in constant 2015 US$) in Latvia in 1999 to that in 2002?
Make the answer very short. 0.86. What is the ratio of the Taxes (in constant 2015 US$) of Solomon Islands in 1999 to that in 2002?
Keep it short and to the point. 4.32. What is the ratio of the Taxes (in constant 2015 US$) of Bolivia in 1999 to that in 2003?
Ensure brevity in your answer.  0.97. What is the ratio of the Taxes (in constant 2015 US$) in Faeroe Islands in 1999 to that in 2003?
Your answer should be very brief. 0.73. What is the ratio of the Taxes (in constant 2015 US$) of Latvia in 1999 to that in 2003?
Your response must be concise. 0.67. What is the ratio of the Taxes (in constant 2015 US$) in Solomon Islands in 1999 to that in 2003?
Keep it short and to the point. 3.47. What is the ratio of the Taxes (in constant 2015 US$) of Bolivia in 1999 to that in 2004?
Offer a terse response. 0.87. What is the ratio of the Taxes (in constant 2015 US$) in Faeroe Islands in 1999 to that in 2004?
Provide a short and direct response. 0.65. What is the ratio of the Taxes (in constant 2015 US$) of Latvia in 1999 to that in 2004?
Offer a terse response. 0.55. What is the ratio of the Taxes (in constant 2015 US$) of Solomon Islands in 1999 to that in 2004?
Ensure brevity in your answer.  3.16. What is the ratio of the Taxes (in constant 2015 US$) in Bolivia in 2000 to that in 2001?
Give a very brief answer. 1.09. What is the ratio of the Taxes (in constant 2015 US$) of Faeroe Islands in 2000 to that in 2001?
Keep it short and to the point. 0.97. What is the ratio of the Taxes (in constant 2015 US$) in Bolivia in 2000 to that in 2002?
Your answer should be compact. 1.11. What is the ratio of the Taxes (in constant 2015 US$) of Faeroe Islands in 2000 to that in 2002?
Offer a very short reply. 0.84. What is the ratio of the Taxes (in constant 2015 US$) in Latvia in 2000 to that in 2002?
Ensure brevity in your answer.  0.89. What is the ratio of the Taxes (in constant 2015 US$) in Solomon Islands in 2000 to that in 2002?
Make the answer very short. 3.1. What is the ratio of the Taxes (in constant 2015 US$) of Bolivia in 2000 to that in 2003?
Offer a very short reply. 1.09. What is the ratio of the Taxes (in constant 2015 US$) in Faeroe Islands in 2000 to that in 2003?
Your response must be concise. 0.68. What is the ratio of the Taxes (in constant 2015 US$) of Latvia in 2000 to that in 2003?
Ensure brevity in your answer.  0.69. What is the ratio of the Taxes (in constant 2015 US$) in Solomon Islands in 2000 to that in 2003?
Offer a very short reply. 2.5. What is the ratio of the Taxes (in constant 2015 US$) in Bolivia in 2000 to that in 2004?
Your response must be concise. 0.98. What is the ratio of the Taxes (in constant 2015 US$) of Faeroe Islands in 2000 to that in 2004?
Your answer should be very brief. 0.61. What is the ratio of the Taxes (in constant 2015 US$) in Latvia in 2000 to that in 2004?
Offer a terse response. 0.57. What is the ratio of the Taxes (in constant 2015 US$) in Solomon Islands in 2000 to that in 2004?
Make the answer very short. 2.27. What is the ratio of the Taxes (in constant 2015 US$) in Bolivia in 2001 to that in 2002?
Your answer should be compact. 1.02. What is the ratio of the Taxes (in constant 2015 US$) of Faeroe Islands in 2001 to that in 2002?
Provide a short and direct response. 0.87. What is the ratio of the Taxes (in constant 2015 US$) in Latvia in 2001 to that in 2002?
Offer a terse response. 0.89. What is the ratio of the Taxes (in constant 2015 US$) of Bolivia in 2001 to that in 2003?
Offer a very short reply. 1. What is the ratio of the Taxes (in constant 2015 US$) of Faeroe Islands in 2001 to that in 2003?
Your response must be concise. 0.7. What is the ratio of the Taxes (in constant 2015 US$) in Latvia in 2001 to that in 2003?
Provide a succinct answer. 0.69. What is the ratio of the Taxes (in constant 2015 US$) of Bolivia in 2001 to that in 2004?
Your response must be concise. 0.9. What is the ratio of the Taxes (in constant 2015 US$) of Faeroe Islands in 2001 to that in 2004?
Your response must be concise. 0.63. What is the ratio of the Taxes (in constant 2015 US$) in Latvia in 2001 to that in 2004?
Provide a short and direct response. 0.57. What is the ratio of the Taxes (in constant 2015 US$) in Bolivia in 2002 to that in 2003?
Make the answer very short. 0.99. What is the ratio of the Taxes (in constant 2015 US$) in Faeroe Islands in 2002 to that in 2003?
Keep it short and to the point. 0.81. What is the ratio of the Taxes (in constant 2015 US$) in Latvia in 2002 to that in 2003?
Provide a short and direct response. 0.77. What is the ratio of the Taxes (in constant 2015 US$) in Solomon Islands in 2002 to that in 2003?
Your answer should be compact. 0.8. What is the ratio of the Taxes (in constant 2015 US$) of Bolivia in 2002 to that in 2004?
Your answer should be compact. 0.88. What is the ratio of the Taxes (in constant 2015 US$) of Faeroe Islands in 2002 to that in 2004?
Provide a succinct answer. 0.73. What is the ratio of the Taxes (in constant 2015 US$) in Latvia in 2002 to that in 2004?
Your response must be concise. 0.64. What is the ratio of the Taxes (in constant 2015 US$) of Solomon Islands in 2002 to that in 2004?
Offer a very short reply. 0.73. What is the ratio of the Taxes (in constant 2015 US$) of Bolivia in 2003 to that in 2004?
Make the answer very short. 0.89. What is the ratio of the Taxes (in constant 2015 US$) of Faeroe Islands in 2003 to that in 2004?
Ensure brevity in your answer.  0.9. What is the ratio of the Taxes (in constant 2015 US$) of Latvia in 2003 to that in 2004?
Offer a terse response. 0.83. What is the ratio of the Taxes (in constant 2015 US$) in Solomon Islands in 2003 to that in 2004?
Your answer should be compact. 0.91. What is the difference between the highest and the second highest Taxes (in constant 2015 US$) in Bolivia?
Provide a short and direct response. 2.86e+07. What is the difference between the highest and the second highest Taxes (in constant 2015 US$) in Faeroe Islands?
Offer a terse response. 2.33e+07. What is the difference between the highest and the second highest Taxes (in constant 2015 US$) of Latvia?
Give a very brief answer. 2.58e+08. What is the difference between the highest and the second highest Taxes (in constant 2015 US$) of Solomon Islands?
Your response must be concise. 7.27e+06. What is the difference between the highest and the lowest Taxes (in constant 2015 US$) in Bolivia?
Ensure brevity in your answer.  1.58e+08. What is the difference between the highest and the lowest Taxes (in constant 2015 US$) of Faeroe Islands?
Provide a succinct answer. 9.09e+07. What is the difference between the highest and the lowest Taxes (in constant 2015 US$) of Latvia?
Offer a very short reply. 6.59e+08. What is the difference between the highest and the lowest Taxes (in constant 2015 US$) in Solomon Islands?
Offer a very short reply. 2.58e+07. 